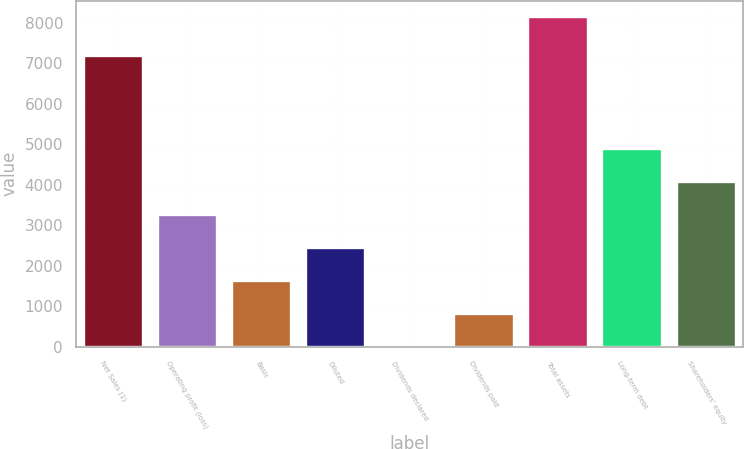Convert chart. <chart><loc_0><loc_0><loc_500><loc_500><bar_chart><fcel>Net Sales (1)<fcel>Operating profit (loss)<fcel>Basic<fcel>Diluted<fcel>Dividends declared<fcel>Dividends paid<fcel>Total assets<fcel>Long-term debt<fcel>Shareholders' equity<nl><fcel>7183<fcel>3255.78<fcel>1628.04<fcel>2441.91<fcel>0.3<fcel>814.17<fcel>8139<fcel>4883.52<fcel>4069.65<nl></chart> 